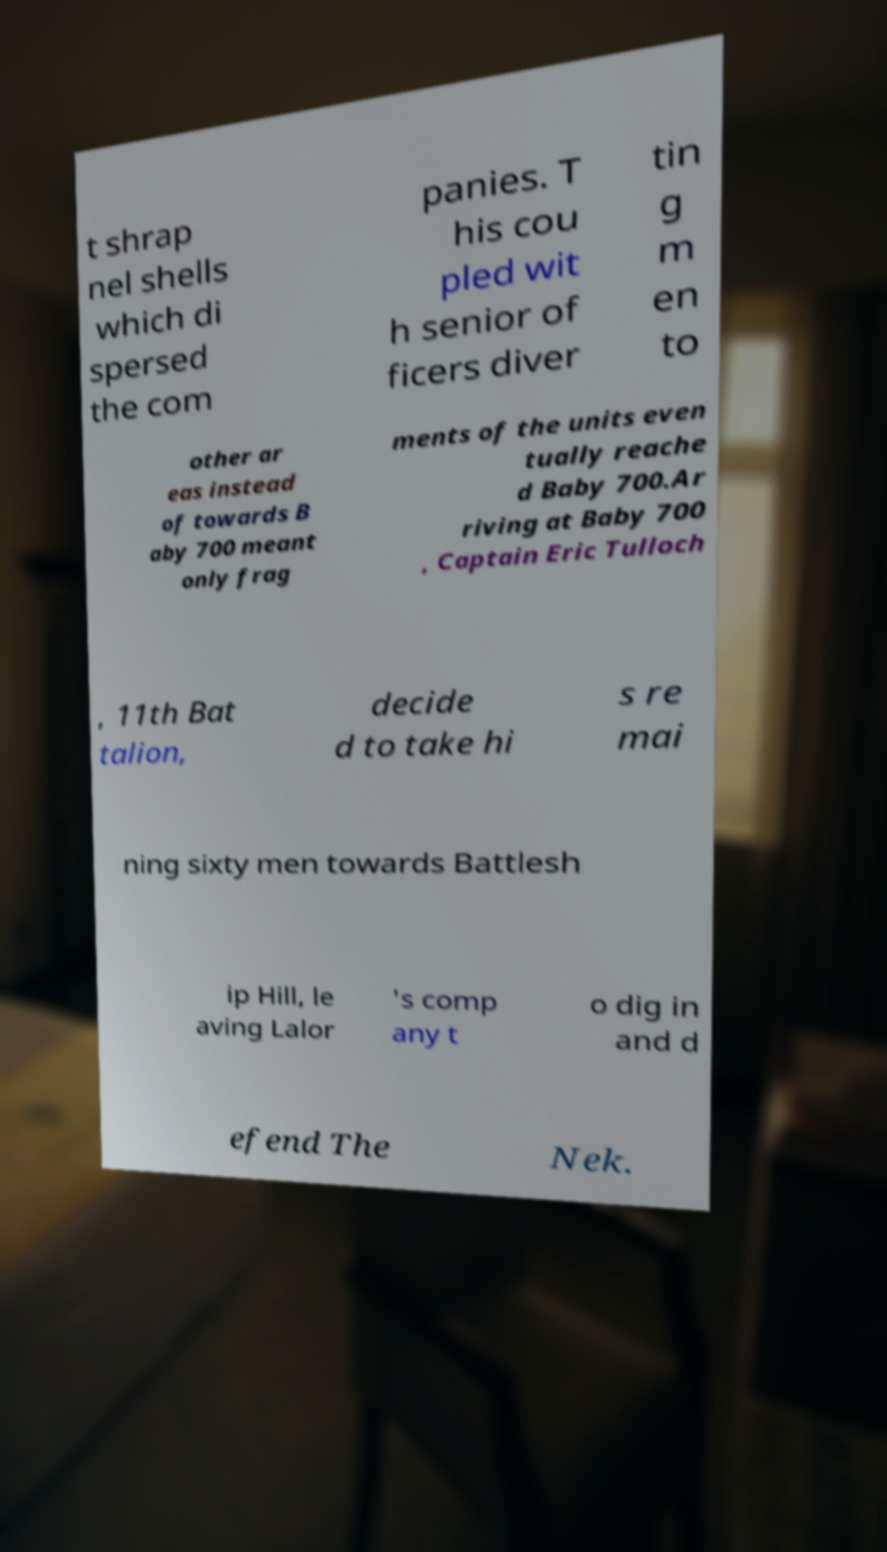Could you assist in decoding the text presented in this image and type it out clearly? t shrap nel shells which di spersed the com panies. T his cou pled wit h senior of ficers diver tin g m en to other ar eas instead of towards B aby 700 meant only frag ments of the units even tually reache d Baby 700.Ar riving at Baby 700 , Captain Eric Tulloch , 11th Bat talion, decide d to take hi s re mai ning sixty men towards Battlesh ip Hill, le aving Lalor 's comp any t o dig in and d efend The Nek. 